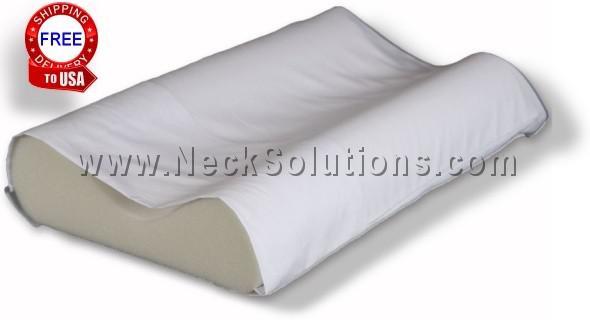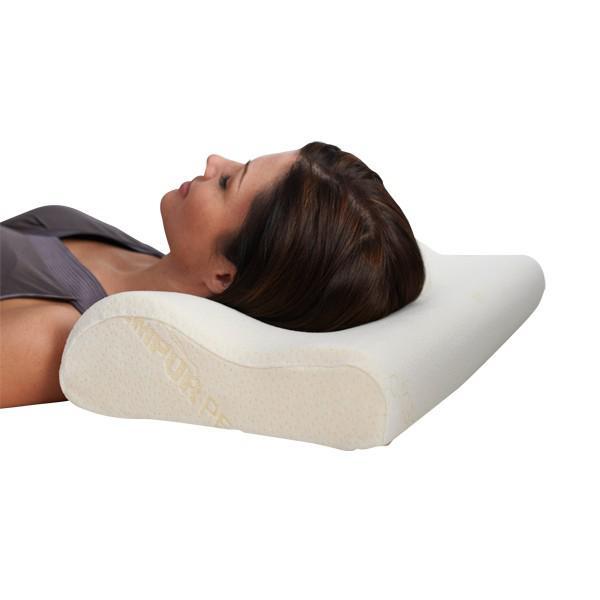The first image is the image on the left, the second image is the image on the right. Assess this claim about the two images: "A brunette woman is sleeping on a pillow". Correct or not? Answer yes or no. Yes. The first image is the image on the left, the second image is the image on the right. For the images shown, is this caption "In one image, a woman with dark hair rests her head on a pillow" true? Answer yes or no. Yes. 